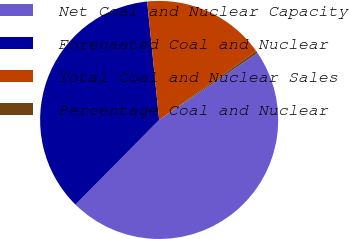<chart> <loc_0><loc_0><loc_500><loc_500><pie_chart><fcel>Net Coal and Nuclear Capacity<fcel>Forecasted Coal and Nuclear<fcel>Total Coal and Nuclear Sales<fcel>Percentage Coal and Nuclear<nl><fcel>46.9%<fcel>35.98%<fcel>16.77%<fcel>0.34%<nl></chart> 